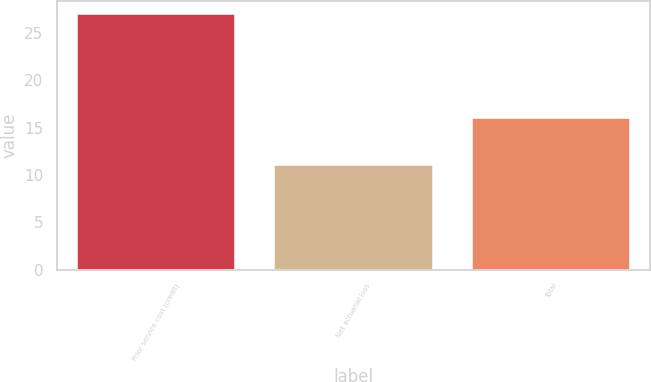<chart> <loc_0><loc_0><loc_500><loc_500><bar_chart><fcel>Prior service cost (credit)<fcel>Net actuarial loss<fcel>Total<nl><fcel>27<fcel>11<fcel>16<nl></chart> 